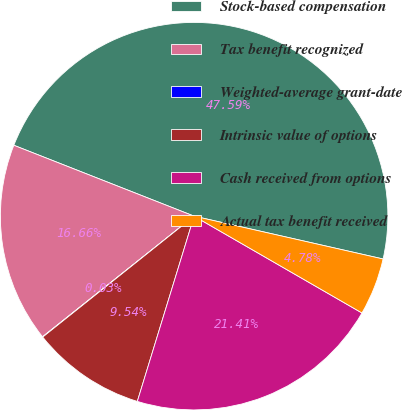<chart> <loc_0><loc_0><loc_500><loc_500><pie_chart><fcel>Stock-based compensation<fcel>Tax benefit recognized<fcel>Weighted-average grant-date<fcel>Intrinsic value of options<fcel>Cash received from options<fcel>Actual tax benefit received<nl><fcel>47.59%<fcel>16.66%<fcel>0.03%<fcel>9.54%<fcel>21.41%<fcel>4.78%<nl></chart> 